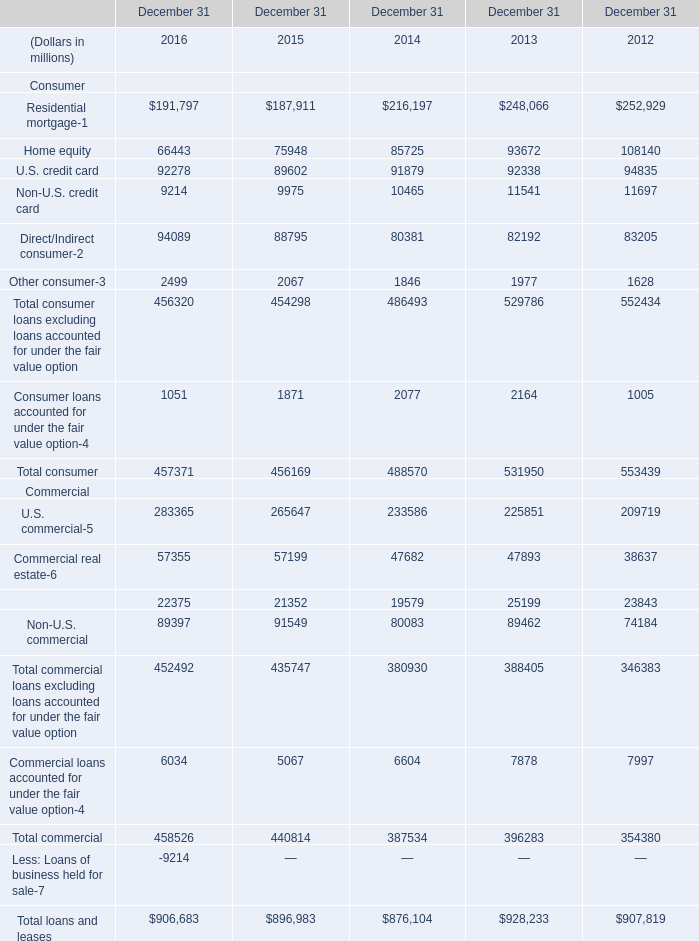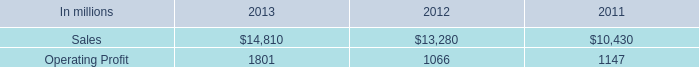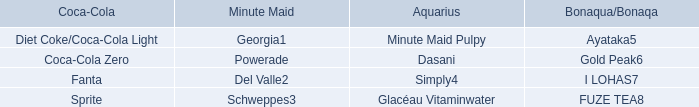what percentage of industrial packaging sales where represented by north american industrial packaging net sales in 2012? 
Computations: ((11.6 * 1000) / 13280)
Answer: 0.87349. 